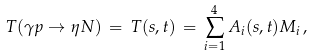Convert formula to latex. <formula><loc_0><loc_0><loc_500><loc_500>T ( \gamma p \rightarrow \eta N ) \, = \, T ( s , t ) \, = \, \sum _ { i = 1 } ^ { 4 } A _ { i } ( s , t ) M _ { i } \, ,</formula> 